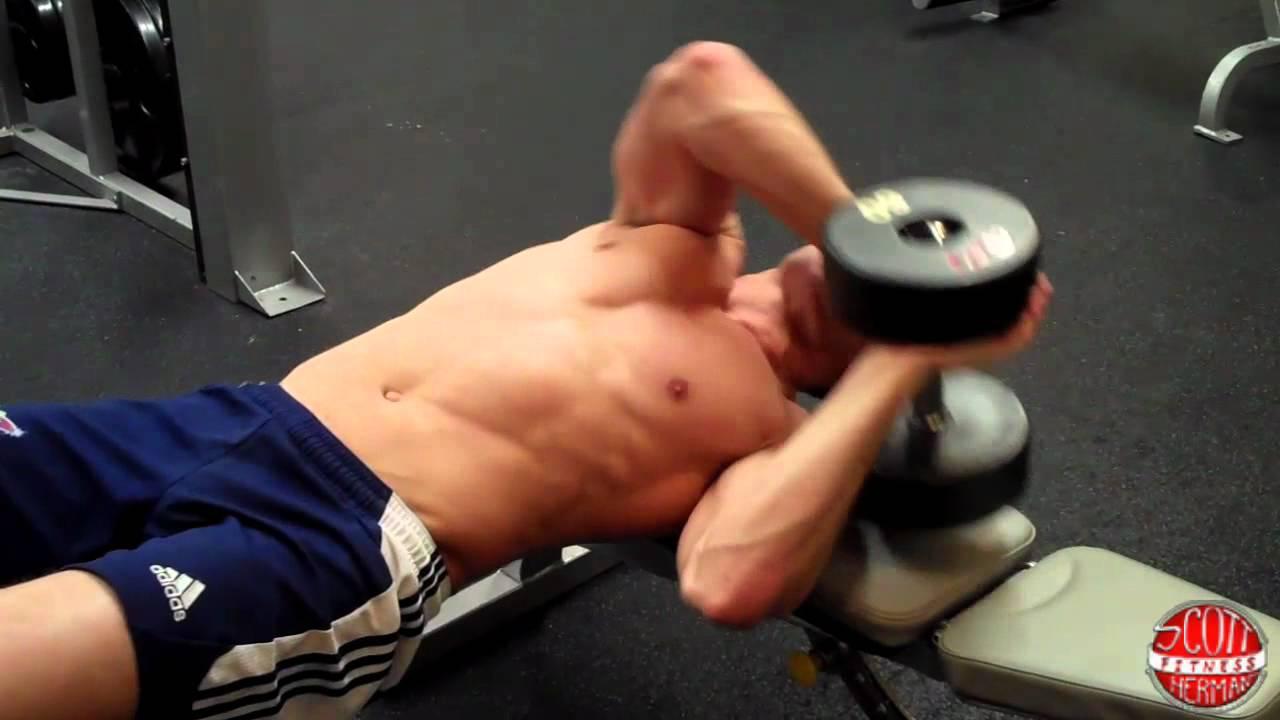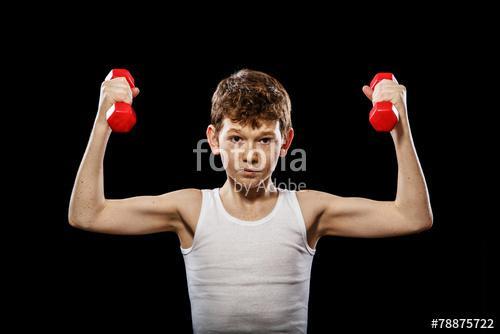The first image is the image on the left, the second image is the image on the right. For the images displayed, is the sentence "The person in the image on the left is holding one black barbell." factually correct? Answer yes or no. Yes. 